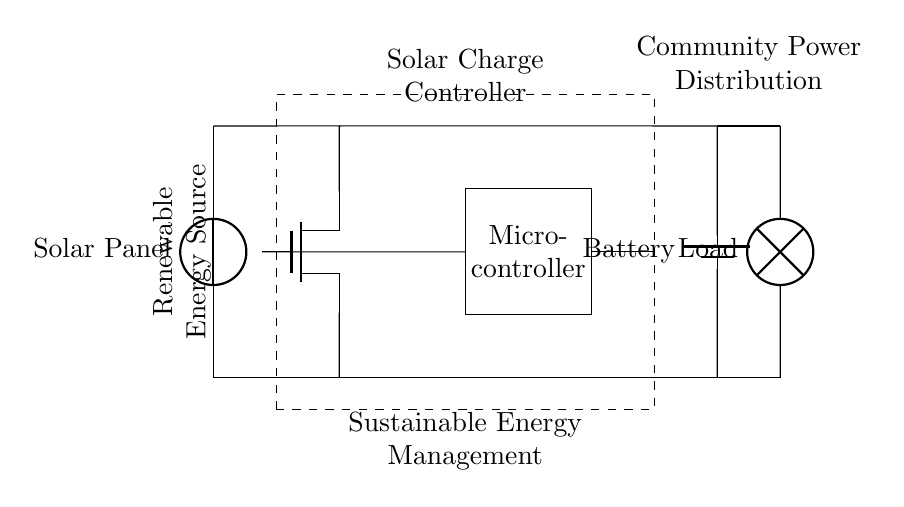What component regulates the flow of energy from the solar panel? The energy from the solar panel is regulated by the solar charge controller, which is indicated by the dashed rectangle around it in the diagram.
Answer: Solar charge controller What type of switch is used in the circuit? The circuit employs an n-channel MOSFET as the switch, which is shown as a node labeled 'mos' in the diagram.
Answer: N-channel MOSFET Where does the load receive its power from? The load receives its power directly from the battery, which is connected to the load via the line leading from the battery in the circuit diagram.
Answer: Battery What is the purpose of the microcontroller in the circuit? The microcontroller is used for managing the overall performance of the solar charge controller and ensuring efficient battery charging, as indicated by its rectangular representation in the circuit diagram.
Answer: Management How many connections does the MOSFET have? The n-channel MOSFET in the diagram has three connections: source, gate, and drain, represented by 'S', 'G', and 'D' respectively.
Answer: Three connections Which component serves as a renewable energy source? The solar panel directly represents the renewable energy source in the circuit as it is the first component shown in the diagram, generating electrical energy from sunlight.
Answer: Solar panel What kind of load is represented in the circuit? The load in the circuit is depicted as a lamp, which indicates that it serves as a light source powered by the battery within this renewable energy system.
Answer: Lamp 